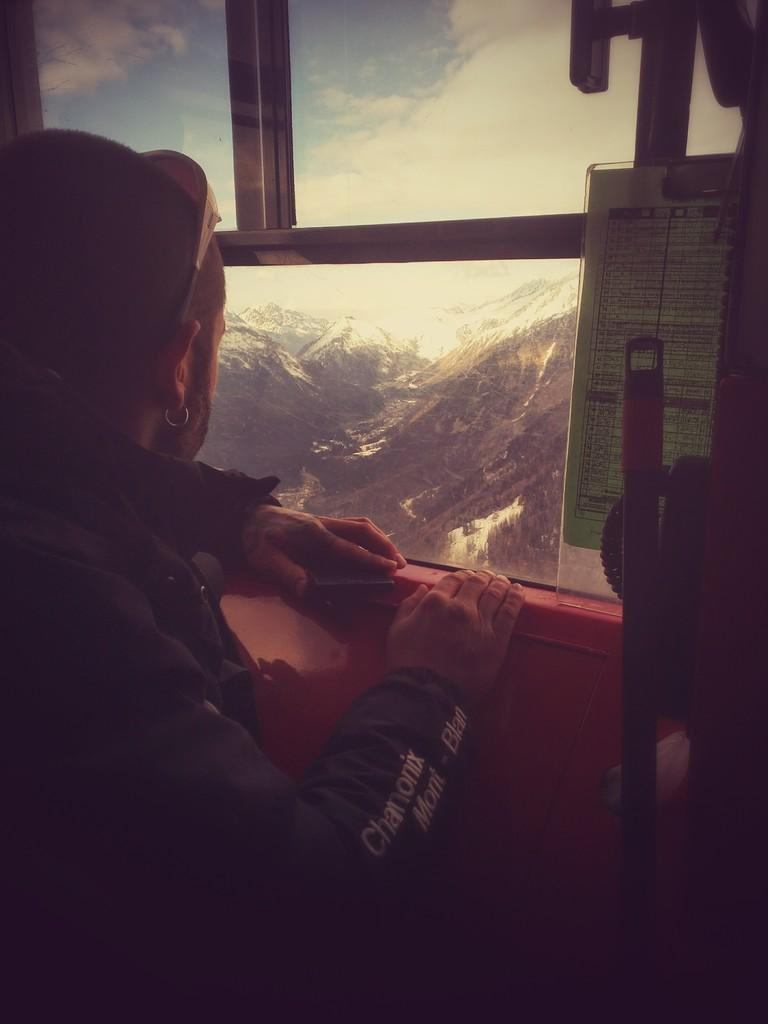Who or what is present in the image? There is a person in the image. What is the main feature of the background in the image? There is a glass window in the image, through which mountains and the sky are visible. What can be found on the right side of the image? There are objects on the right side of the image. What type of riddle can be seen written on the glass window in the image? There is no riddle written on the glass window in the image. How many horses are visible in the image? There are no horses present in the image. 